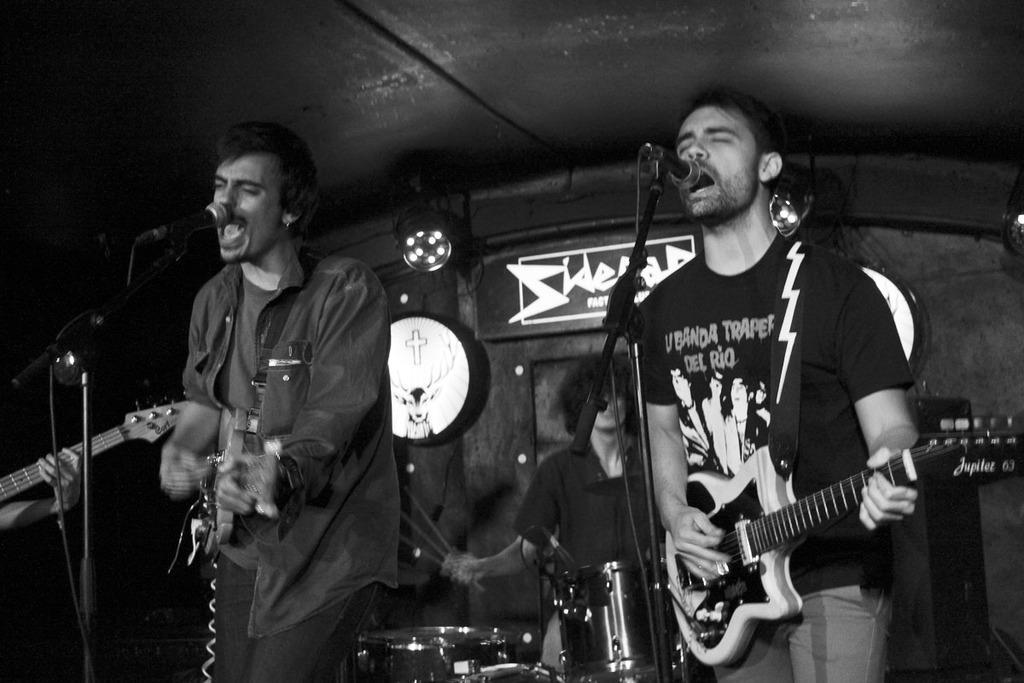Could you give a brief overview of what you see in this image? A black and white picture. These 2 persons are playing a guitar and singing in-front of mic. This person is playing a musical instruments. On top there is a focusing light. 